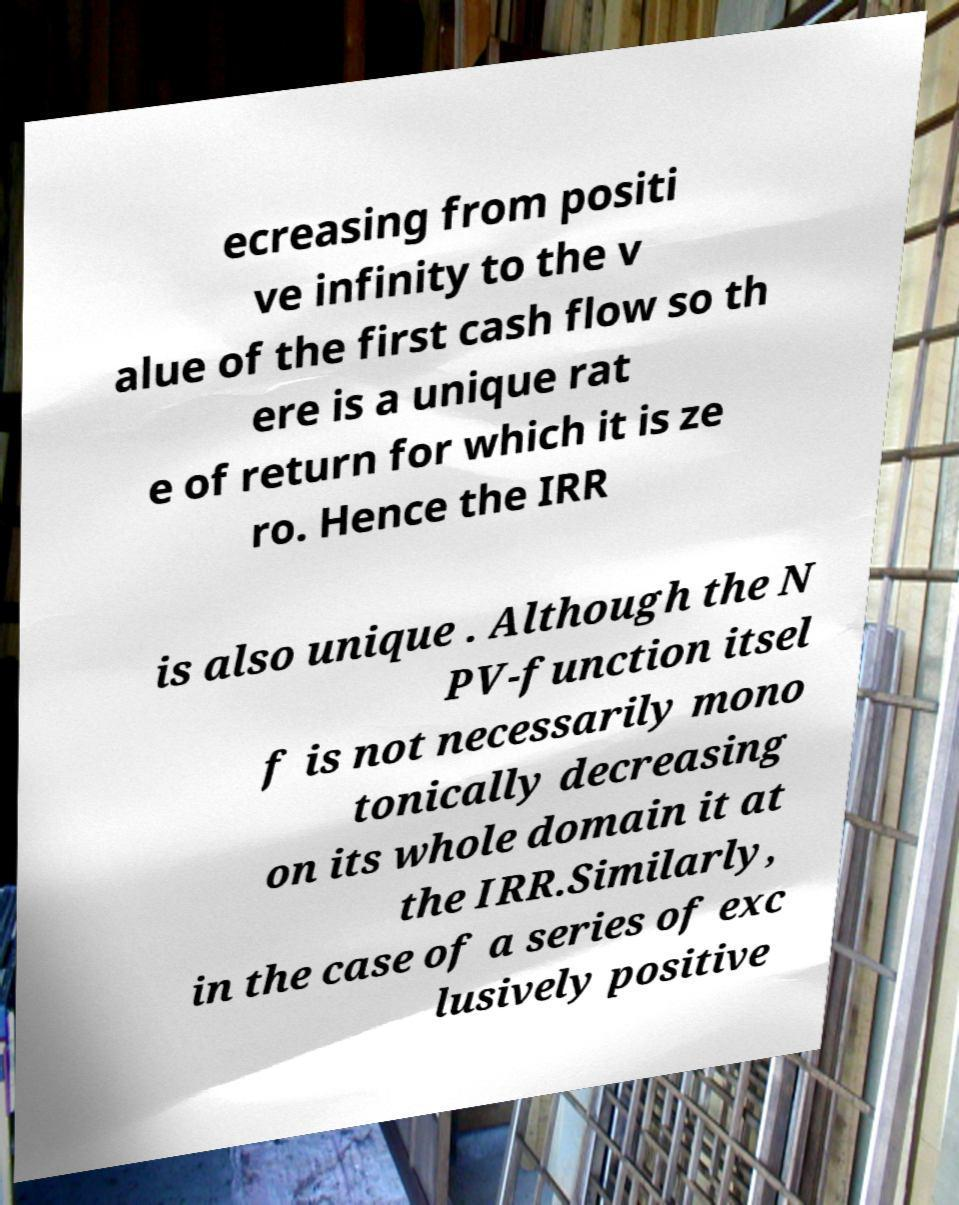I need the written content from this picture converted into text. Can you do that? ecreasing from positi ve infinity to the v alue of the first cash flow so th ere is a unique rat e of return for which it is ze ro. Hence the IRR is also unique . Although the N PV-function itsel f is not necessarily mono tonically decreasing on its whole domain it at the IRR.Similarly, in the case of a series of exc lusively positive 